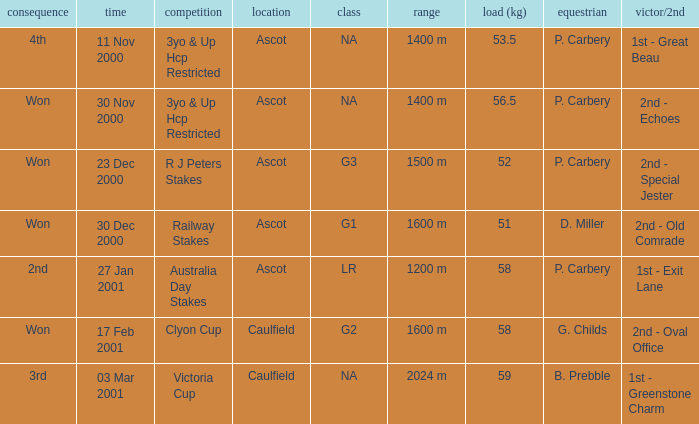What group info is available for the 56.5 kg weight? NA. 